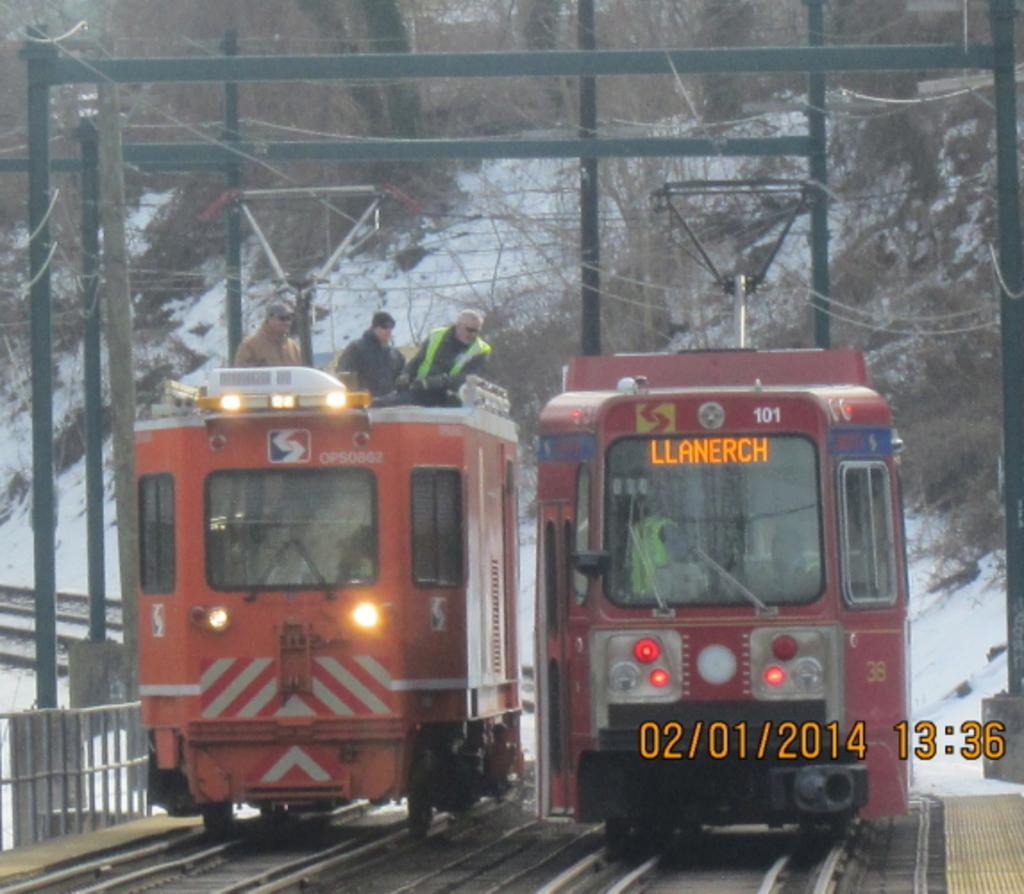Please provide a concise description of this image. In this image we can see some people in the locomotives which are on the track. We can also see a fence, poles and the wires. On the backside we can see some trees and the snow. 